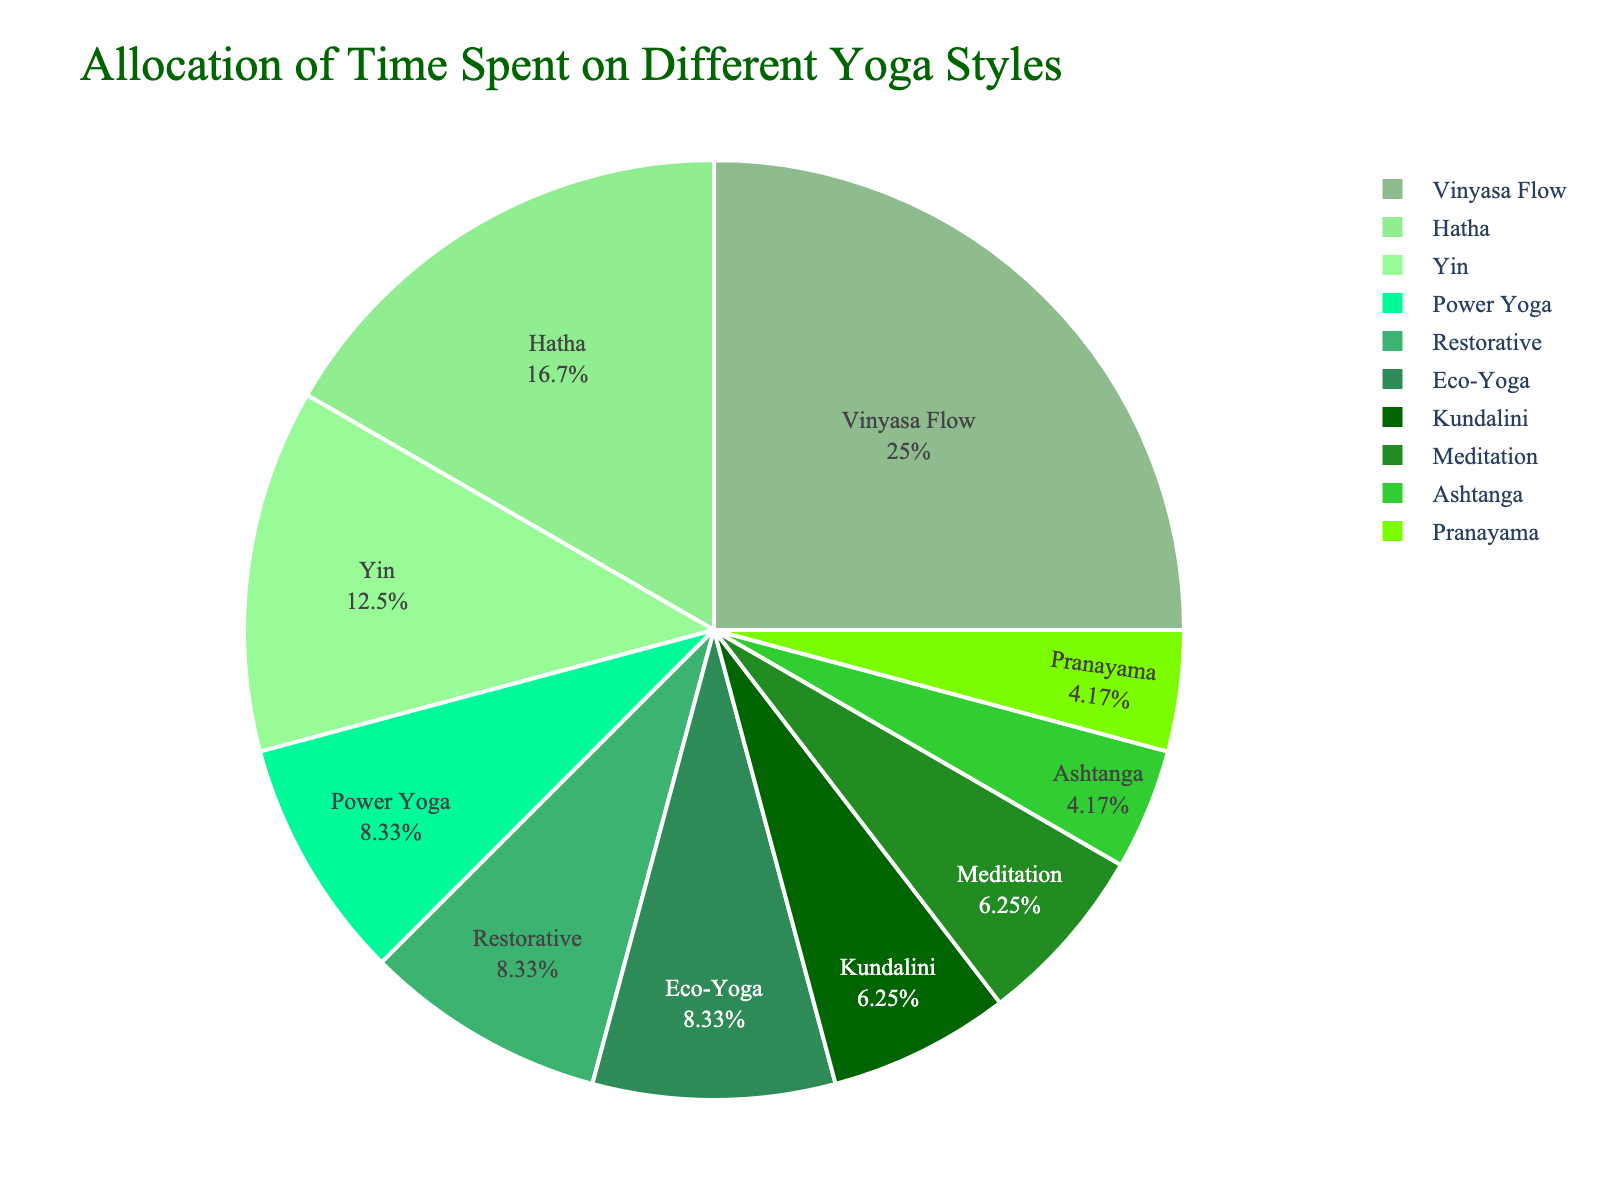What yoga style occupies the largest portion of your weekly practice? By looking at the pie chart, identify the segment with the largest area. This represents the yoga style taking up the most hours in your weekly practice.
Answer: Vinyasa Flow How much time is spent on Hatha and Yin yoga combined? Add the hours spent on Hatha (4) and Yin (3) yoga together: 4 + 3 = 7 hours.
Answer: 7 hours Which yoga styles occupy exactly 2 hours of practice each week? Look for segments labeled with 2 hours. The styles labeled with 2 hours each are Power Yoga, Restorative, and Eco-Yoga.
Answer: Power Yoga, Restorative, Eco-Yoga How much longer do you practice Vinyasa Flow compared to Ashtanga? Subtract the hours for Ashtanga (1) from the hours for Vinyasa Flow (6): 6 - 1 = 5 hours.
Answer: 5 hours What percentage of your total practice is dedicated to Kundalini yoga? The pie chart shows the percentages. Identify the percentage for Kundalini yoga by its segment labeled with 1.5 hours. If not explicitly labeled, divide the hours by the total (24) and multiply by 100: (1.5 / 24) * 100 ≈ 6.25%.
Answer: 6.25% Which yoga style has a similar percentage of time allocation as Meditation? Identify the segment for Meditation (1.5 hours) and find another segment with a similar percentage, which is Kundalini yoga.
Answer: Kundalini Is Restorative yoga practiced more or less than Yin yoga? Compare the segments and see which one is larger. Restorative yoga has 2 hours, while Yin has 3 hours. Therefore, Restorative is practiced less.
Answer: Less Combine the time spent on all yoga styles that are practiced 1.5 hours each week. Add the hours for Kundalini (1.5) and Meditation (1.5): 1.5 + 1.5 = 3 hours.
Answer: 3 hours How many styles are practiced less than or equal to 2 hours weekly? Count the segments representing styles with 2 hours or less. These are Power Yoga, Restorative, Kundalini, Ashtanga, Meditation, and Pranayama, totaling 6 styles.
Answer: 6 styles What is the average time spent on yoga styles that have more than 2 hours of practice? Identify styles with more than 2 hours (Vinyasa Flow, Hatha, Yin). Calculate the average: (6 + 4 + 3) / 3 = 13 / 3 ≈ 4.33 hours.
Answer: 4.33 hours 